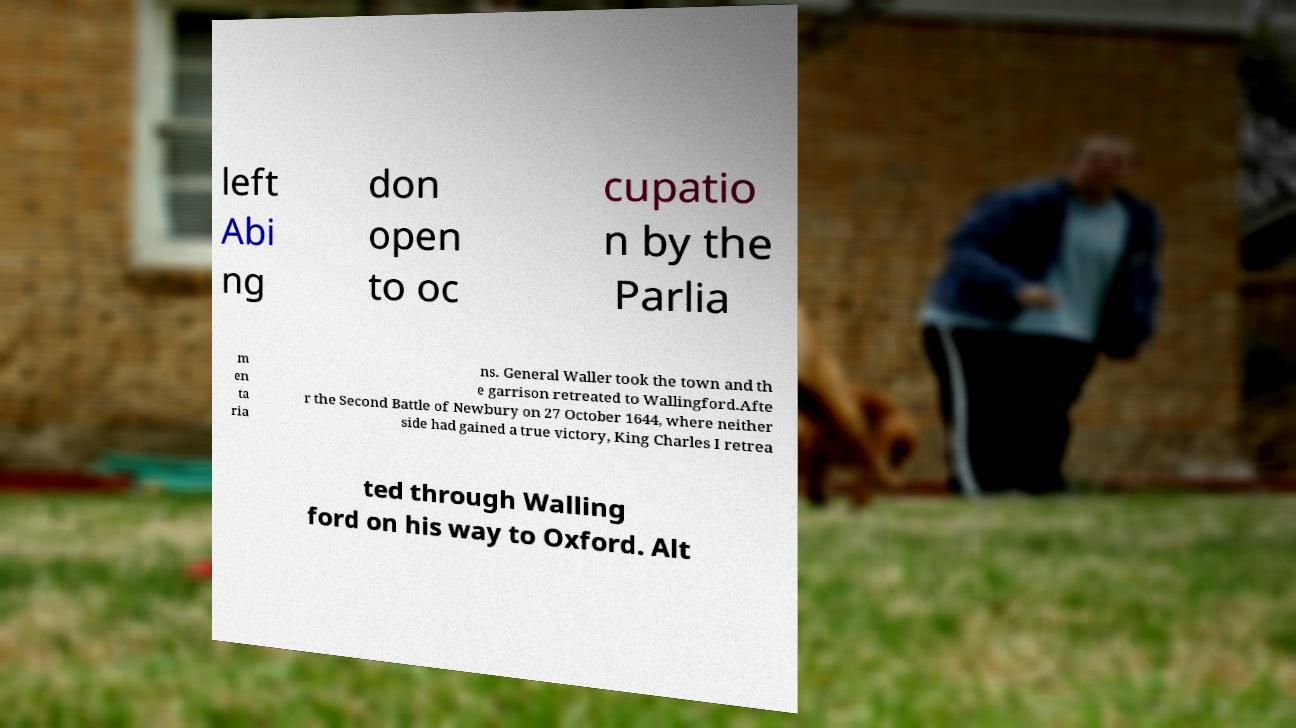Please read and relay the text visible in this image. What does it say? left Abi ng don open to oc cupatio n by the Parlia m en ta ria ns. General Waller took the town and th e garrison retreated to Wallingford.Afte r the Second Battle of Newbury on 27 October 1644, where neither side had gained a true victory, King Charles I retrea ted through Walling ford on his way to Oxford. Alt 